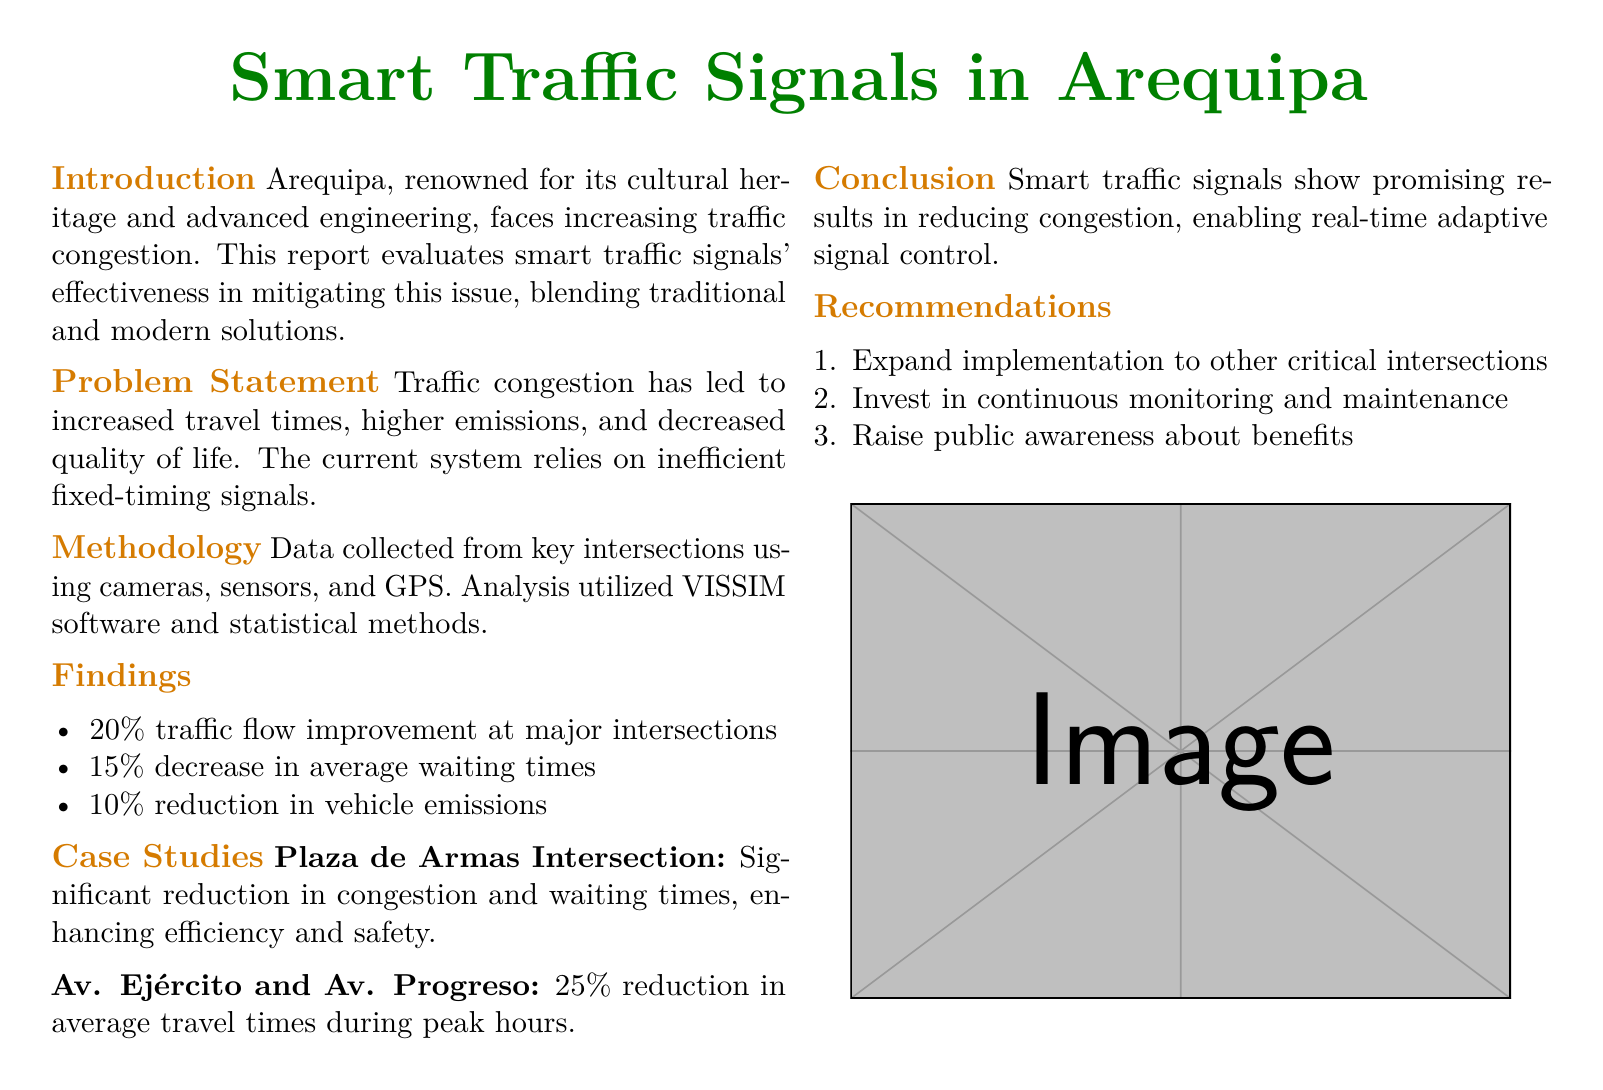What is the percentage improvement in traffic flow at major intersections? The report states that there is a 20% traffic flow improvement at major intersections.
Answer: 20% What reduction in average waiting times was reported? According to the findings, there is a 15% decrease in average waiting times.
Answer: 15% What was the effect on vehicle emissions after implementing smart traffic signals? The document mentions a 10% reduction in vehicle emissions.
Answer: 10% Which intersection showed a significant reduction in congestion and waiting times? The Plaza de Armas Intersection is mentioned as having significant reductions in congestion and waiting times.
Answer: Plaza de Armas Intersection What is a recommended action for future traffic signal implementations? The report recommends expanding implementation to other critical intersections.
Answer: Expand implementation to other critical intersections What methodology was used to gather traffic data? Data was collected using cameras, sensors, and GPS for analysis.
Answer: Cameras, sensors, and GPS What software was used for the analysis in the report? VISSIM software was utilized for the analysis in this study.
Answer: VISSIM What is the primary goal of the report? The report evaluates the effectiveness of smart traffic signals in reducing congestion.
Answer: Reduce congestion What was the reduction in average travel times at Av. Ejército and Av. Progreso during peak hours? The report indicates a 25% reduction in average travel times during peak hours at that intersection.
Answer: 25% 